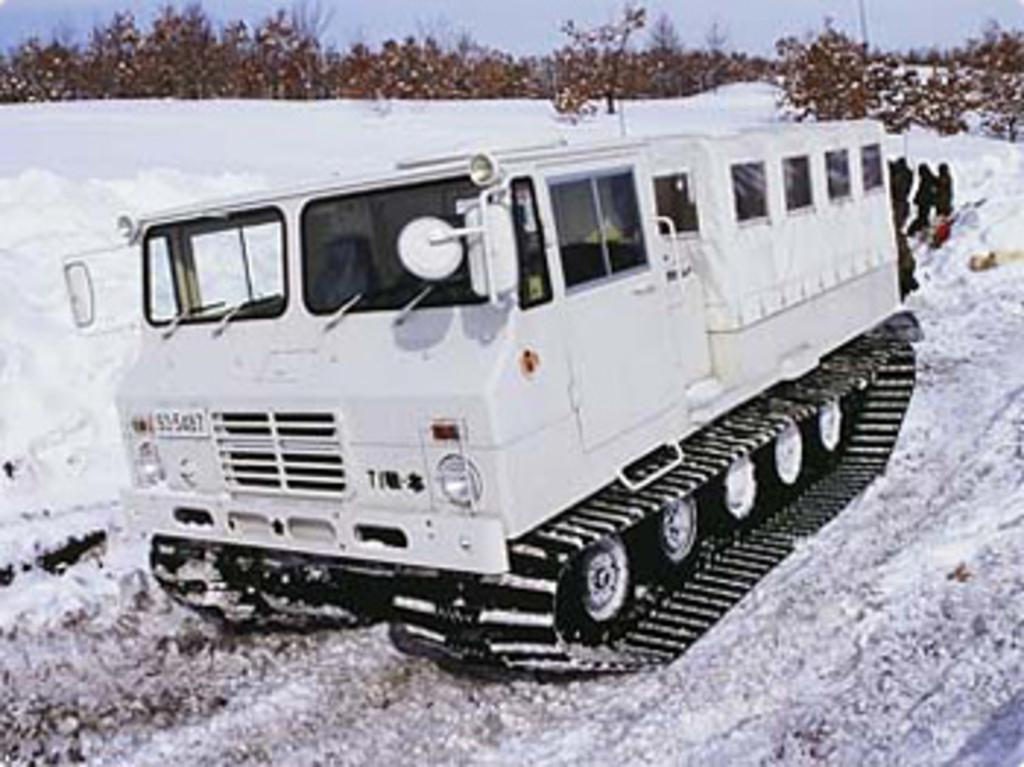What type of vehicle is in the image? There is an artillery tractor in the image. What is the terrain where the artillery tractor is located? The artillery tractor is on the snow. Are there any people visible in the image? Yes, there are people standing in the image. What type of natural elements can be seen in the image? There are trees in the image. Where is the nest of the bird located in the image? There is no nest or bird present in the image. What type of bulb is used to light up the area in the image? There is no mention of any bulbs or lighting in the image. 